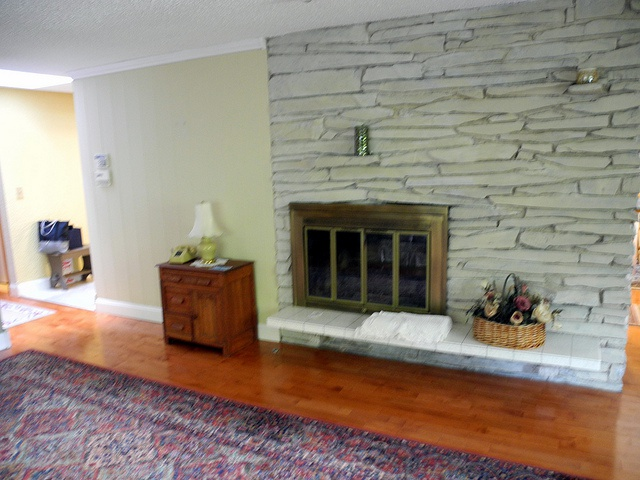Describe the objects in this image and their specific colors. I can see a handbag in gray, darkgray, navy, and black tones in this image. 